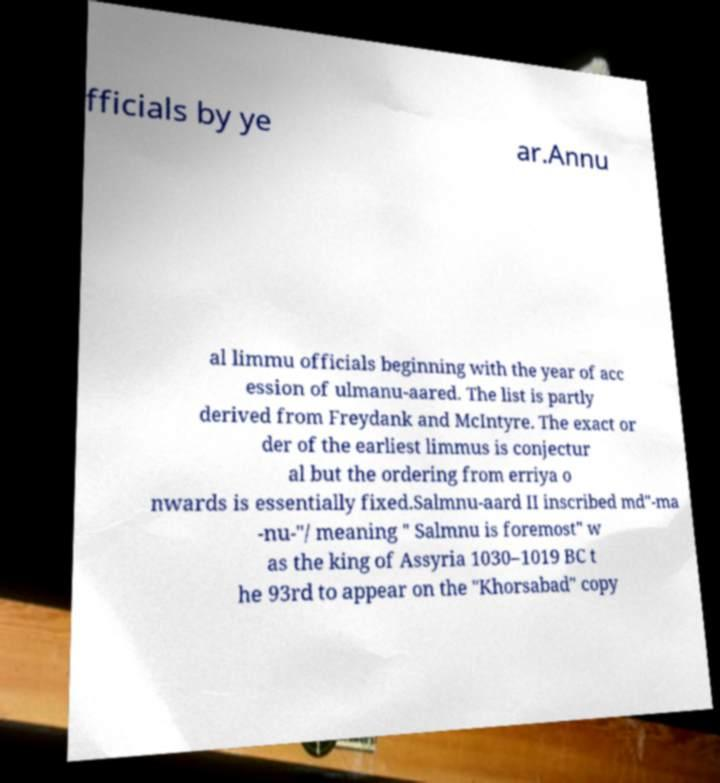Please identify and transcribe the text found in this image. fficials by ye ar.Annu al limmu officials beginning with the year of acc ession of ulmanu-aared. The list is partly derived from Freydank and McIntyre. The exact or der of the earliest limmus is conjectur al but the ordering from erriya o nwards is essentially fixed.Salmnu-aard II inscribed md"-ma -nu-"/ meaning " Salmnu is foremost" w as the king of Assyria 1030–1019 BC t he 93rd to appear on the "Khorsabad" copy 